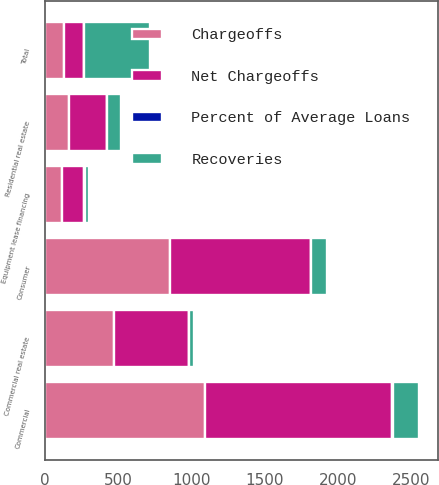<chart> <loc_0><loc_0><loc_500><loc_500><stacked_bar_chart><ecel><fcel>Commercial<fcel>Commercial real estate<fcel>Equipment lease financing<fcel>Consumer<fcel>Residential real estate<fcel>Total<nl><fcel>Net Chargeoffs<fcel>1276<fcel>510<fcel>149<fcel>961<fcel>259<fcel>135.5<nl><fcel>Recoveries<fcel>181<fcel>38<fcel>27<fcel>105<fcel>93<fcel>444<nl><fcel>Chargeoffs<fcel>1095<fcel>472<fcel>122<fcel>856<fcel>166<fcel>135.5<nl><fcel>Percent of Average Loans<fcel>1.79<fcel>1.91<fcel>1.97<fcel>1.63<fcel>0.79<fcel>1.64<nl></chart> 